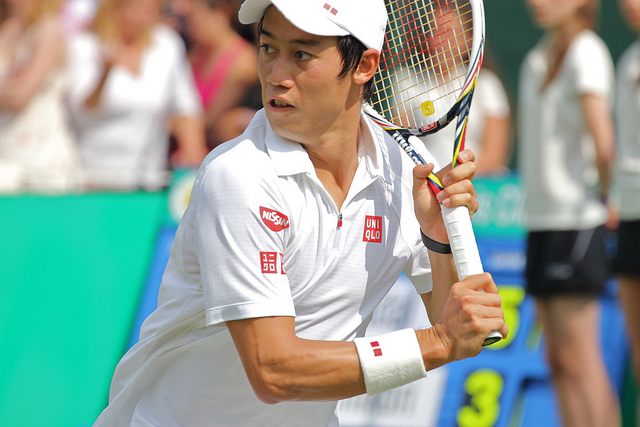Read and extract the text from this image. NISSAN UNI QLO 3 